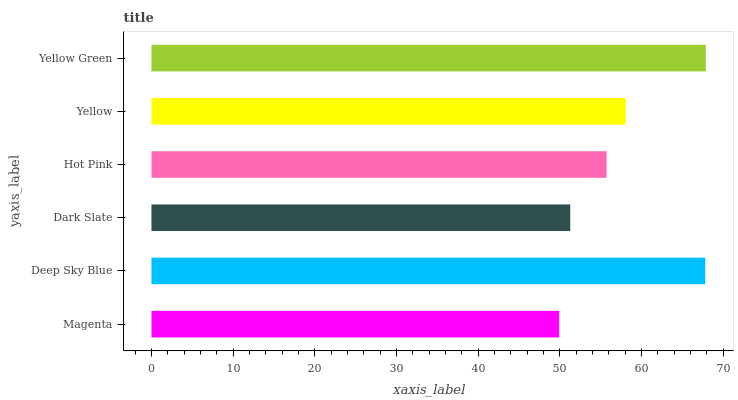Is Magenta the minimum?
Answer yes or no. Yes. Is Yellow Green the maximum?
Answer yes or no. Yes. Is Deep Sky Blue the minimum?
Answer yes or no. No. Is Deep Sky Blue the maximum?
Answer yes or no. No. Is Deep Sky Blue greater than Magenta?
Answer yes or no. Yes. Is Magenta less than Deep Sky Blue?
Answer yes or no. Yes. Is Magenta greater than Deep Sky Blue?
Answer yes or no. No. Is Deep Sky Blue less than Magenta?
Answer yes or no. No. Is Yellow the high median?
Answer yes or no. Yes. Is Hot Pink the low median?
Answer yes or no. Yes. Is Magenta the high median?
Answer yes or no. No. Is Yellow Green the low median?
Answer yes or no. No. 